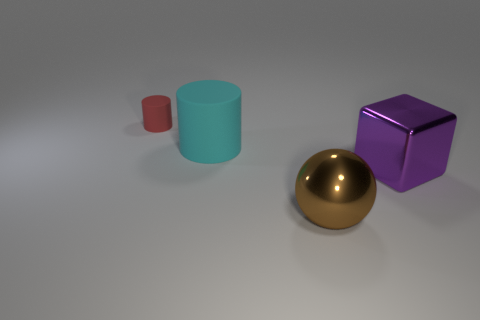What is the texture and color of the object to the right of the large cyan cylinder? The object to the right of the large cyan cylinder features a shiny, reflective surface and is colored in a luxurious shade of gold.  Compared to the other objects, how would you describe the size of the gold object? The gold object has a medium size when compared to the surrounding objects. It's larger than the small pink cylinder but smaller than both the cyan cylinder and the purple cube. 